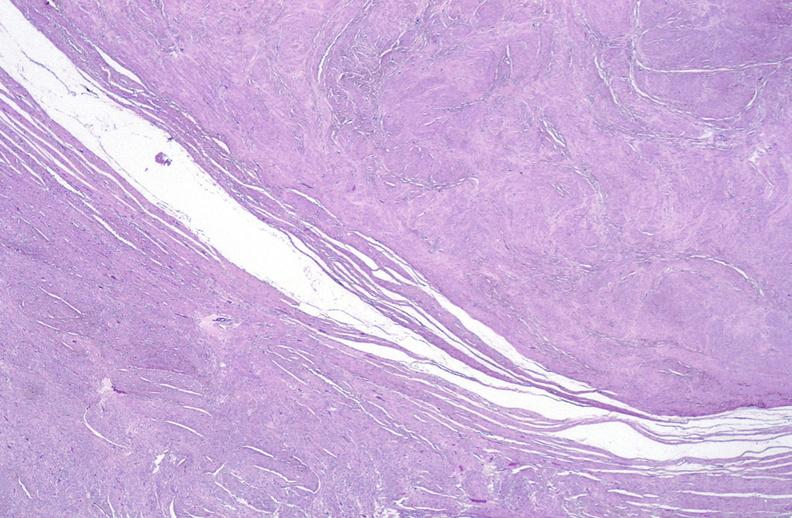where is this from?
Answer the question using a single word or phrase. Female reproductive system 